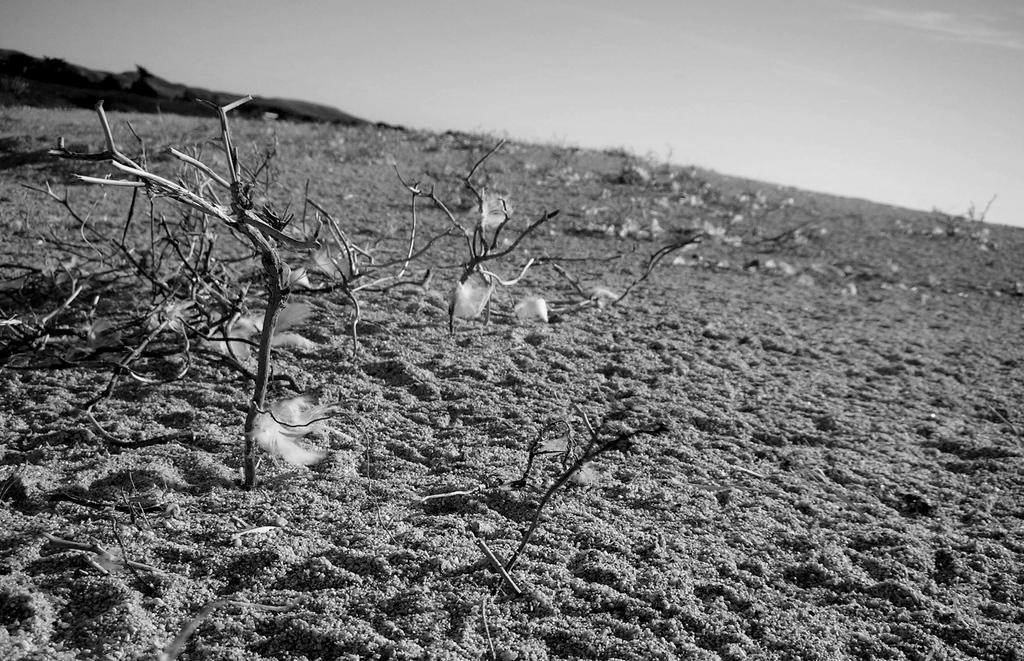Describe this image in one or two sentences. This is a black and white image. There is sand at the bottom. There are small plants in the middle. There is sky at the top. 